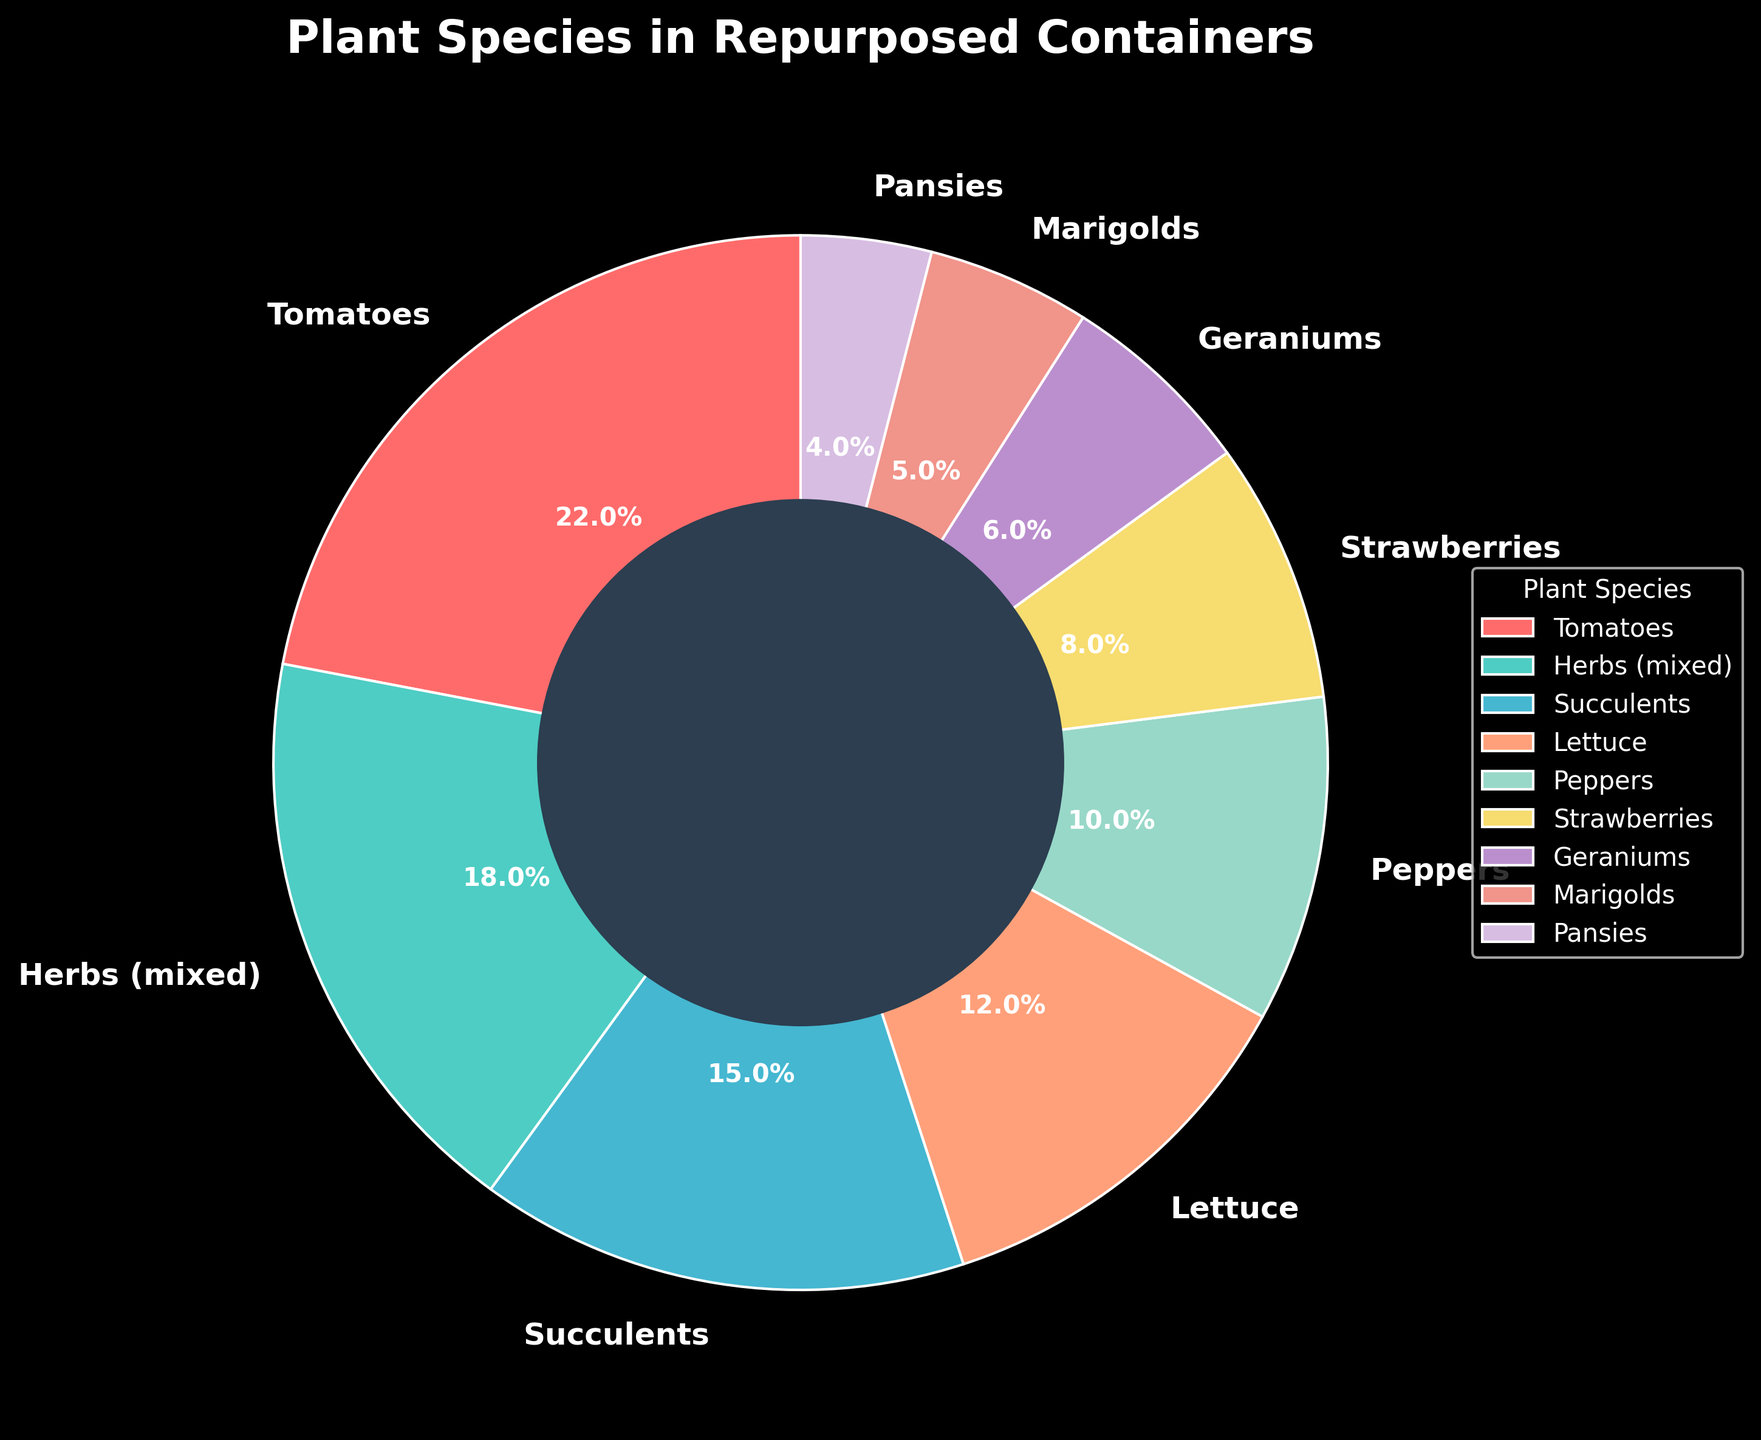What's the most frequently grown plant species in repurposed containers? The pie chart shows the different plant species with their respective percentages. The largest wedge, representing 22%, is for Tomatoes, indicating it is the most frequently grown species.
Answer: Tomatoes Which plant species is least frequently grown in repurposed containers? By observing the pie chart, the smallest wedge belongs to Pansies, with a percentage of 4%, making it the least frequently grown species.
Answer: Pansies What is the combined percentage of Tomatoes, Succulents, and Lettuce? The respective percentages of Tomatoes, Succulents, and Lettuce are 22%, 15%, and 12%. Summing these gives 22 + 15 + 12 = 49%.
Answer: 49% How many plant species have a percentage greater than 10%? By analyzing the pie chart, the species with more than 10% are Tomatoes (22%), Herbs (mixed) (18%), Succulents (15%), and Lettuce (12%)—a total of 4 species.
Answer: 4 Are there more herb species or flower species in the chart, and by how much? Identifying each category: Herbs include only "Herbs (mixed)" while flowers include Geraniums, Marigolds, and Pansies. Herbs are 18% and flowers combined are 6% + 5% + 4% = 15%. Thus, herbs exceed flowers by 18% - 15% = 3%.
Answer: Herbs, by 3% Which species appears in green color and what is its percentage? From the pie chart, the green-colored wedge represents the "Herbs (mixed)" with a percentage of 18%.
Answer: Herbs (mixed), 18% What is the difference in percentage between the species with the highest and the species with the lowest representation in containers? The highest percentage is for Tomatoes at 22%, and the lowest is for Pansies at 4%. The difference is 22% - 4% = 18%.
Answer: 18% What is the percentage of fruit-bearing plants in the chart and which species does this include? Fruit-bearing plants include Tomatoes and Strawberries. Their percentages are 22% and 8%, respectively. Totaling them gives 22% + 8% = 30%.
Answer: 30% If you grouped all flowers into a single category, what would their total percentage be? The flowers are Geraniums (6%), Marigolds (5%), and Pansies (4%). Summing these, 6 + 5 + 4 = 15%.
Answer: 15% 